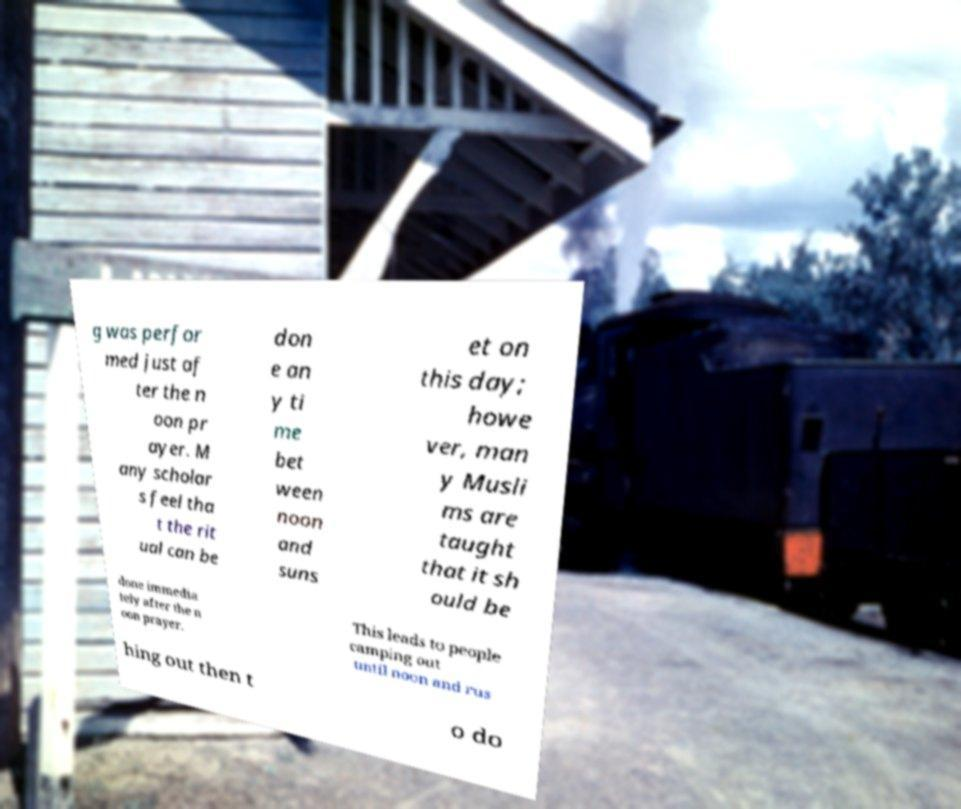Please identify and transcribe the text found in this image. g was perfor med just af ter the n oon pr ayer. M any scholar s feel tha t the rit ual can be don e an y ti me bet ween noon and suns et on this day; howe ver, man y Musli ms are taught that it sh ould be done immedia tely after the n oon prayer. This leads to people camping out until noon and rus hing out then t o do 